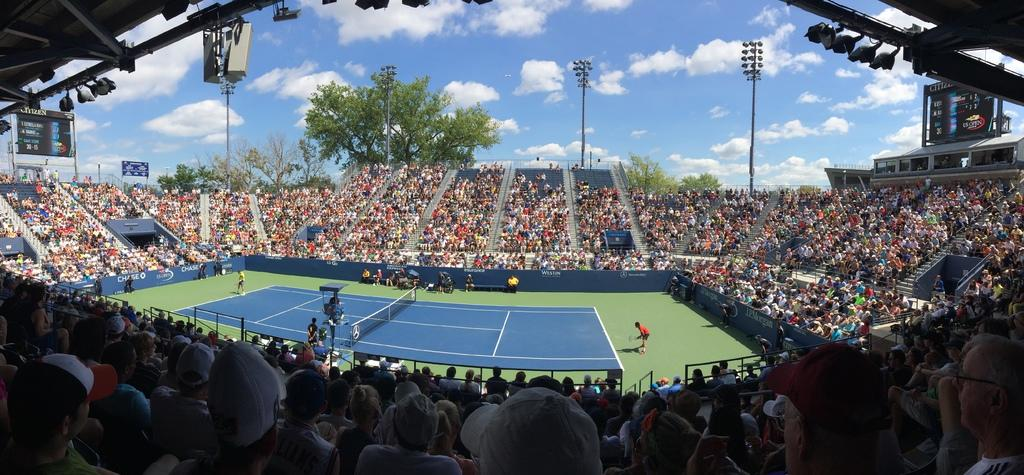What type of structure is visible in the image? There is a stadium in the image. Can you describe the people in the image? There are people in the image, but their specific actions or positions are not clear. What can be seen in the background of the image? There are trees and the sky visible in the background of the image. What are the light poles used for in the image? The light poles are likely used for providing illumination during events held at the stadium. What type of soup is being served on the plate in the image? There is no soup or plate present in the image; it features a stadium with people, trees, and light poles. 